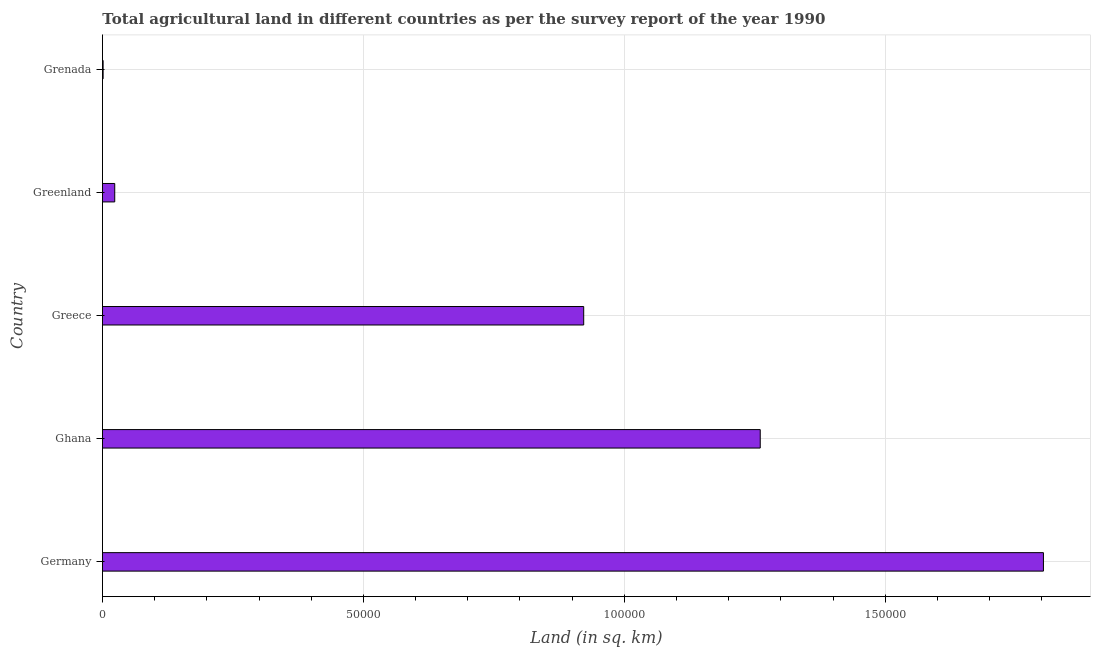Does the graph contain any zero values?
Provide a succinct answer. No. What is the title of the graph?
Provide a short and direct response. Total agricultural land in different countries as per the survey report of the year 1990. What is the label or title of the X-axis?
Provide a short and direct response. Land (in sq. km). What is the label or title of the Y-axis?
Offer a very short reply. Country. What is the agricultural land in Germany?
Your response must be concise. 1.80e+05. Across all countries, what is the maximum agricultural land?
Keep it short and to the point. 1.80e+05. Across all countries, what is the minimum agricultural land?
Your answer should be compact. 130. In which country was the agricultural land maximum?
Make the answer very short. Germany. In which country was the agricultural land minimum?
Make the answer very short. Grenada. What is the sum of the agricultural land?
Make the answer very short. 4.01e+05. What is the difference between the agricultural land in Ghana and Greece?
Your response must be concise. 3.38e+04. What is the average agricultural land per country?
Give a very brief answer. 8.02e+04. What is the median agricultural land?
Make the answer very short. 9.22e+04. What is the ratio of the agricultural land in Ghana to that in Greece?
Offer a very short reply. 1.37. Is the agricultural land in Greece less than that in Greenland?
Offer a terse response. No. What is the difference between the highest and the second highest agricultural land?
Give a very brief answer. 5.43e+04. Is the sum of the agricultural land in Germany and Grenada greater than the maximum agricultural land across all countries?
Give a very brief answer. Yes. What is the difference between the highest and the lowest agricultural land?
Make the answer very short. 1.80e+05. What is the difference between two consecutive major ticks on the X-axis?
Your response must be concise. 5.00e+04. What is the Land (in sq. km) in Germany?
Make the answer very short. 1.80e+05. What is the Land (in sq. km) in Ghana?
Make the answer very short. 1.26e+05. What is the Land (in sq. km) of Greece?
Provide a succinct answer. 9.22e+04. What is the Land (in sq. km) of Greenland?
Offer a very short reply. 2355. What is the Land (in sq. km) in Grenada?
Provide a succinct answer. 130. What is the difference between the Land (in sq. km) in Germany and Ghana?
Your answer should be compact. 5.43e+04. What is the difference between the Land (in sq. km) in Germany and Greece?
Offer a terse response. 8.81e+04. What is the difference between the Land (in sq. km) in Germany and Greenland?
Your response must be concise. 1.78e+05. What is the difference between the Land (in sq. km) in Germany and Grenada?
Offer a very short reply. 1.80e+05. What is the difference between the Land (in sq. km) in Ghana and Greece?
Offer a terse response. 3.38e+04. What is the difference between the Land (in sq. km) in Ghana and Greenland?
Offer a terse response. 1.24e+05. What is the difference between the Land (in sq. km) in Ghana and Grenada?
Keep it short and to the point. 1.26e+05. What is the difference between the Land (in sq. km) in Greece and Greenland?
Offer a very short reply. 8.99e+04. What is the difference between the Land (in sq. km) in Greece and Grenada?
Offer a very short reply. 9.21e+04. What is the difference between the Land (in sq. km) in Greenland and Grenada?
Your answer should be compact. 2225. What is the ratio of the Land (in sq. km) in Germany to that in Ghana?
Make the answer very short. 1.43. What is the ratio of the Land (in sq. km) in Germany to that in Greece?
Make the answer very short. 1.96. What is the ratio of the Land (in sq. km) in Germany to that in Greenland?
Your answer should be very brief. 76.57. What is the ratio of the Land (in sq. km) in Germany to that in Grenada?
Offer a very short reply. 1387.08. What is the ratio of the Land (in sq. km) in Ghana to that in Greece?
Ensure brevity in your answer.  1.37. What is the ratio of the Land (in sq. km) in Ghana to that in Greenland?
Provide a succinct answer. 53.52. What is the ratio of the Land (in sq. km) in Ghana to that in Grenada?
Keep it short and to the point. 969.62. What is the ratio of the Land (in sq. km) in Greece to that in Greenland?
Keep it short and to the point. 39.16. What is the ratio of the Land (in sq. km) in Greece to that in Grenada?
Provide a succinct answer. 709.38. What is the ratio of the Land (in sq. km) in Greenland to that in Grenada?
Give a very brief answer. 18.11. 